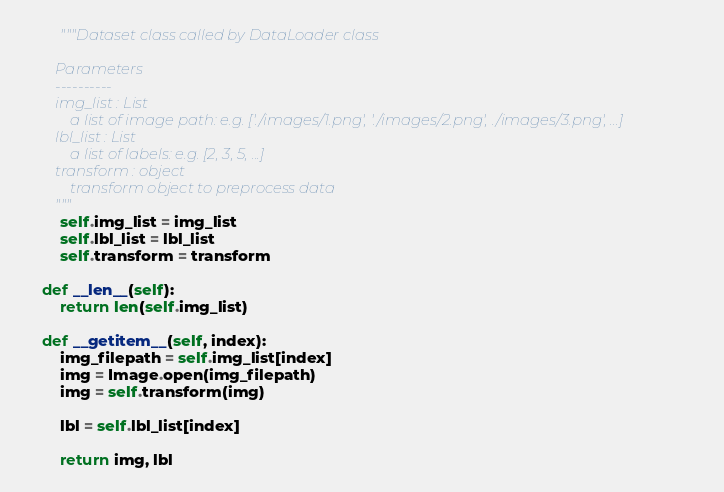<code> <loc_0><loc_0><loc_500><loc_500><_Python_>        """Dataset class called by DataLoader class

        Parameters
        ----------
        img_list : List
            a list of image path: e.g. ['./images/1.png', './images/2.png', ./images/3.png', ...]
        lbl_list : List
            a list of labels: e.g. [2, 3, 5, ...]
        transform : object
            transform object to preprocess data
        """
        self.img_list = img_list
        self.lbl_list = lbl_list
        self.transform = transform

    def __len__(self):
        return len(self.img_list)

    def __getitem__(self, index):
        img_filepath = self.img_list[index]
        img = Image.open(img_filepath)
        img = self.transform(img)

        lbl = self.lbl_list[index]

        return img, lbl</code> 